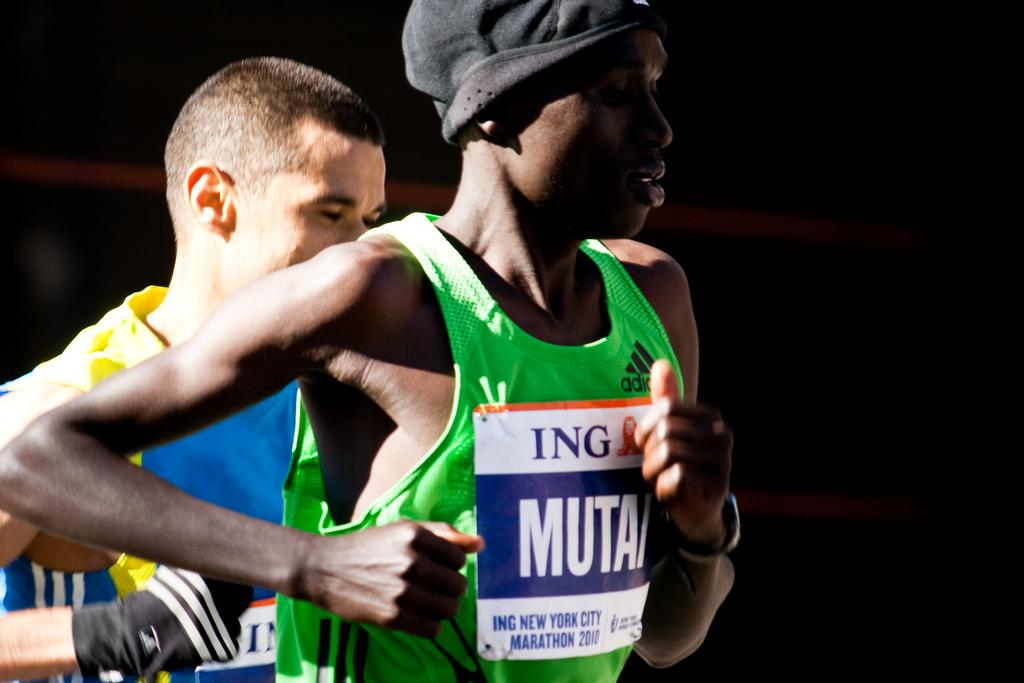How many individuals are present in the image? There are two people in the image. What can be observed about the background of the image? The background of the image is dark. What type of plantation can be seen in the image? There is no plantation present in the image. What magical object is being used by the people in the image? There is no magical object or any indication of magic in the image. 